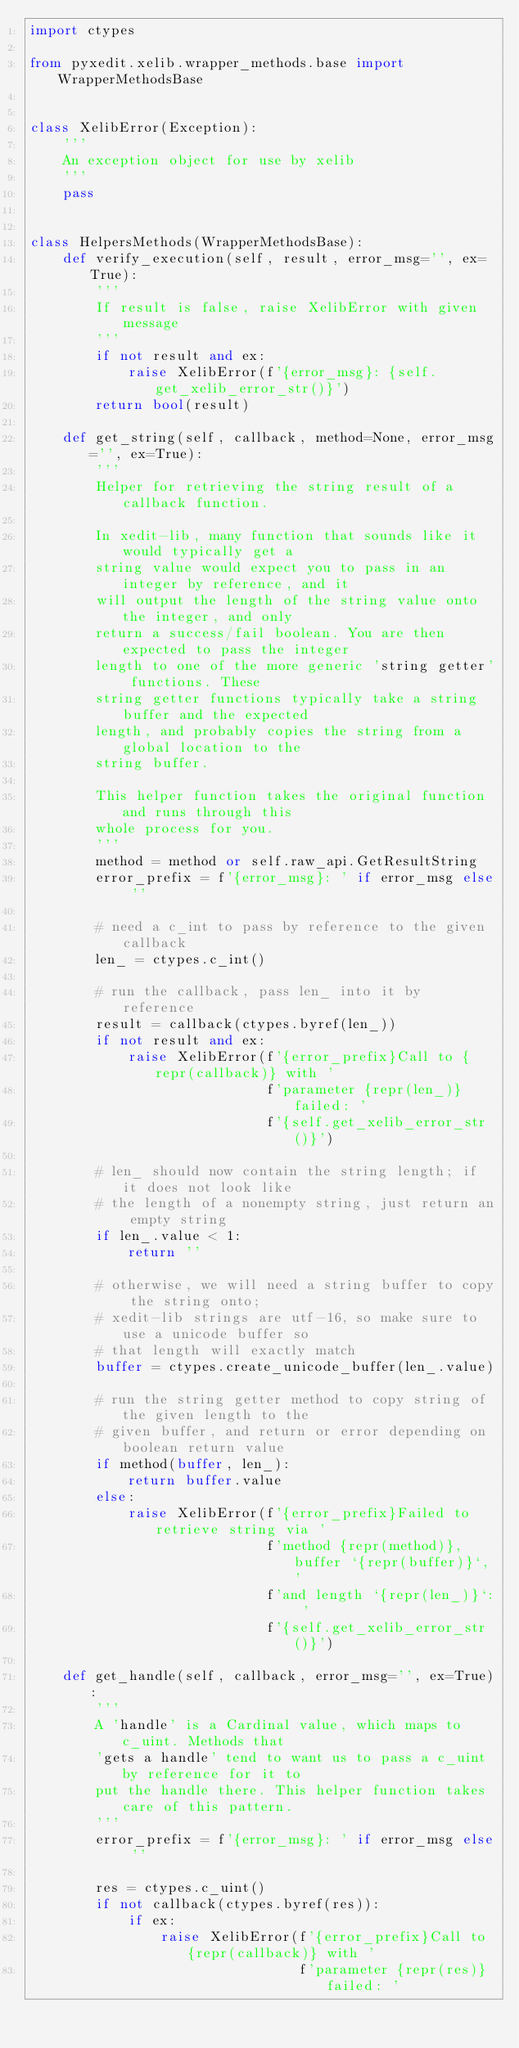<code> <loc_0><loc_0><loc_500><loc_500><_Python_>import ctypes

from pyxedit.xelib.wrapper_methods.base import WrapperMethodsBase


class XelibError(Exception):
    '''
    An exception object for use by xelib
    '''
    pass


class HelpersMethods(WrapperMethodsBase):
    def verify_execution(self, result, error_msg='', ex=True):
        '''
        If result is false, raise XelibError with given message
        '''
        if not result and ex:
            raise XelibError(f'{error_msg}: {self.get_xelib_error_str()}')
        return bool(result)

    def get_string(self, callback, method=None, error_msg='', ex=True):
        '''
        Helper for retrieving the string result of a callback function.

        In xedit-lib, many function that sounds like it would typically get a
        string value would expect you to pass in an integer by reference, and it
        will output the length of the string value onto the integer, and only
        return a success/fail boolean. You are then expected to pass the integer
        length to one of the more generic 'string getter' functions. These
        string getter functions typically take a string buffer and the expected
        length, and probably copies the string from a global location to the
        string buffer.

        This helper function takes the original function and runs through this
        whole process for you.
        '''
        method = method or self.raw_api.GetResultString
        error_prefix = f'{error_msg}: ' if error_msg else ''

        # need a c_int to pass by reference to the given callback
        len_ = ctypes.c_int()

        # run the callback, pass len_ into it by reference
        result = callback(ctypes.byref(len_))
        if not result and ex:
            raise XelibError(f'{error_prefix}Call to {repr(callback)} with '
                             f'parameter {repr(len_)} failed: '
                             f'{self.get_xelib_error_str()}')

        # len_ should now contain the string length; if it does not look like
        # the length of a nonempty string, just return an empty string
        if len_.value < 1:
            return ''

        # otherwise, we will need a string buffer to copy the string onto;
        # xedit-lib strings are utf-16, so make sure to use a unicode buffer so
        # that length will exactly match
        buffer = ctypes.create_unicode_buffer(len_.value)

        # run the string getter method to copy string of the given length to the
        # given buffer, and return or error depending on boolean return value
        if method(buffer, len_):
            return buffer.value
        else:
            raise XelibError(f'{error_prefix}Failed to retrieve string via '
                             f'method {repr(method)}, buffer `{repr(buffer)}`, '
                             f'and length `{repr(len_)}`: '
                             f'{self.get_xelib_error_str()}')

    def get_handle(self, callback, error_msg='', ex=True):
        '''
        A 'handle' is a Cardinal value, which maps to c_uint. Methods that
        'gets a handle' tend to want us to pass a c_uint by reference for it to
        put the handle there. This helper function takes care of this pattern.
        '''
        error_prefix = f'{error_msg}: ' if error_msg else ''

        res = ctypes.c_uint()
        if not callback(ctypes.byref(res)):
            if ex:
                raise XelibError(f'{error_prefix}Call to {repr(callback)} with '
                                 f'parameter {repr(res)} failed: '</code> 